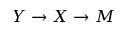Convert formula to latex. <formula><loc_0><loc_0><loc_500><loc_500>Y \rightarrow X \rightarrow M</formula> 